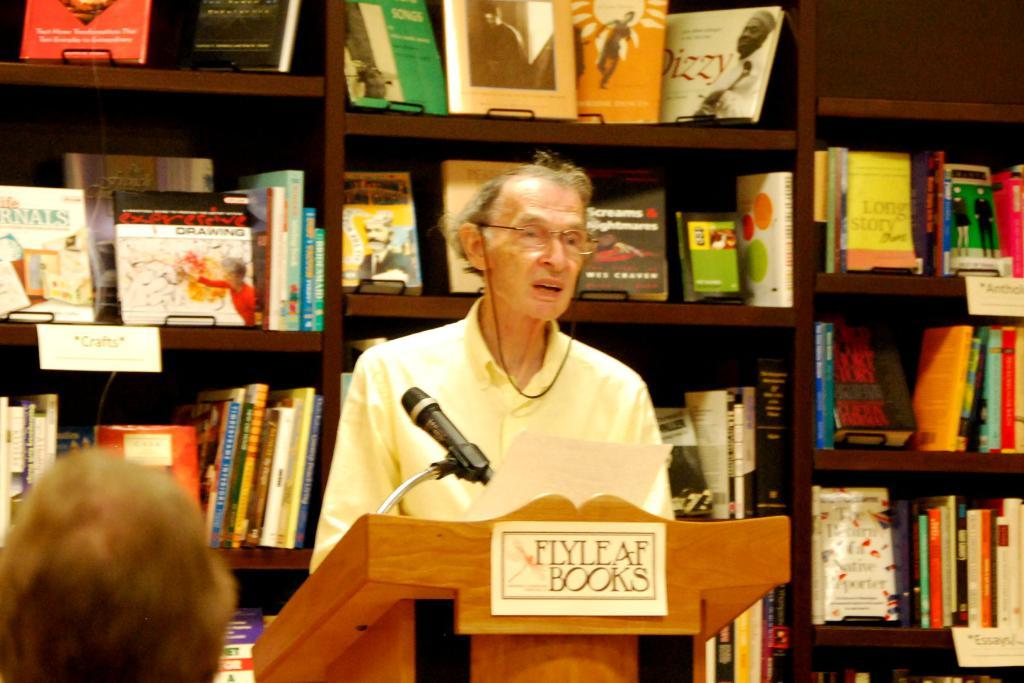<image>
Write a terse but informative summary of the picture. A man is standing at a podium at Flyleaf Books. 